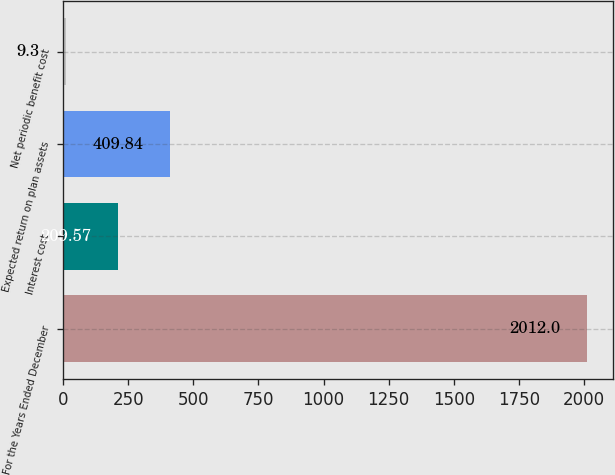<chart> <loc_0><loc_0><loc_500><loc_500><bar_chart><fcel>For the Years Ended December<fcel>Interest cost<fcel>Expected return on plan assets<fcel>Net periodic benefit cost<nl><fcel>2012<fcel>209.57<fcel>409.84<fcel>9.3<nl></chart> 